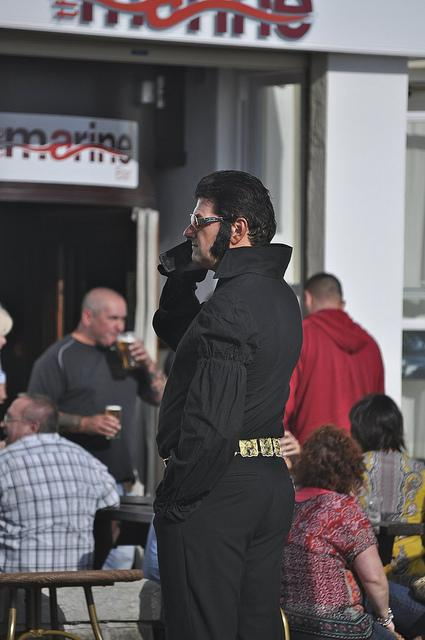The man in black is dressed like what star? Please explain your reasoning. elvis. He has dark hair, sideburns, sunglasses and a jumpsuit, which is what the singer used to wear during performances. 